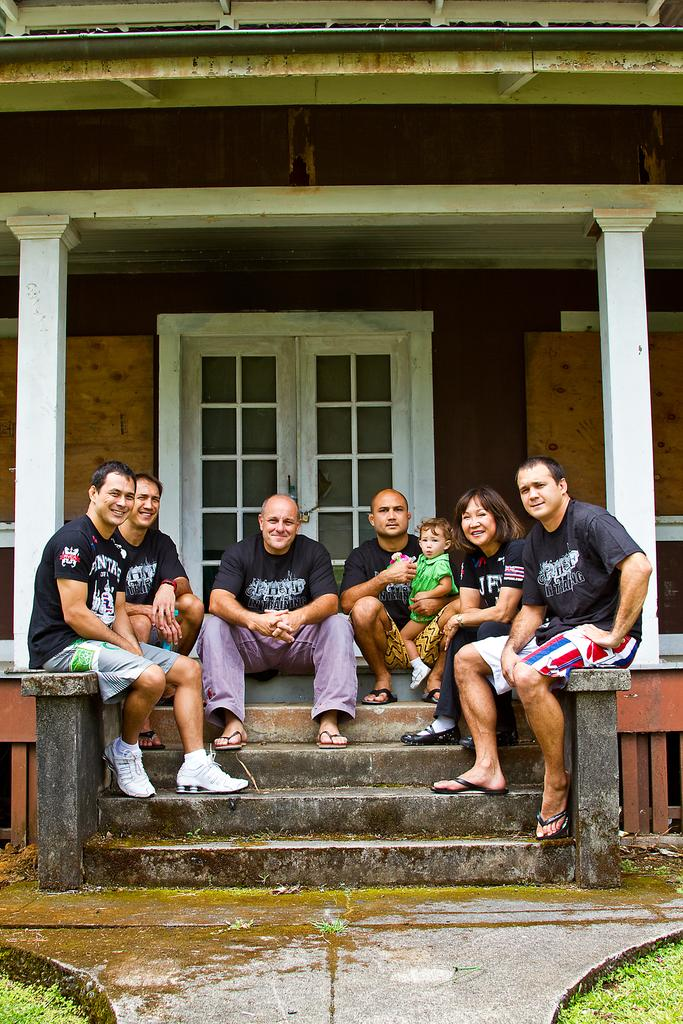What are the people in the image doing? The people in the image are sitting and smiling. What type of surface can be seen beneath the people? There is grass visible in the image. What can be seen on the path in the image? There is water visible on a path in the image. What is visible in the distance behind the people? There is a building in the background of the image. How many pizzas are being held by the people in the image? There are no pizzas visible in the image; the people are not holding any. What color is the grape that is being eaten by the person in the image? There is no grape present in the image, so it cannot be determined what color it might be. 